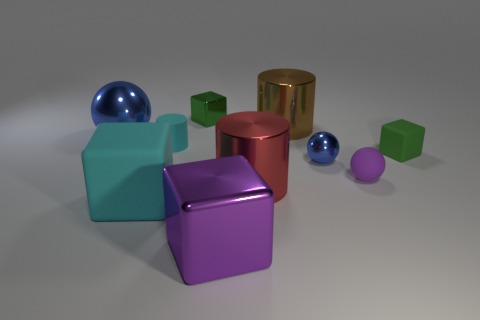Subtract all purple metal blocks. How many blocks are left? 3 Subtract all gray cylinders. How many green cubes are left? 2 Subtract all purple cubes. How many cubes are left? 3 Subtract 1 balls. How many balls are left? 2 Subtract all cylinders. How many objects are left? 7 Subtract all gray cylinders. Subtract all brown blocks. How many cylinders are left? 3 Subtract all purple balls. Subtract all big red objects. How many objects are left? 8 Add 5 tiny rubber cylinders. How many tiny rubber cylinders are left? 6 Add 2 small things. How many small things exist? 7 Subtract 0 gray cubes. How many objects are left? 10 